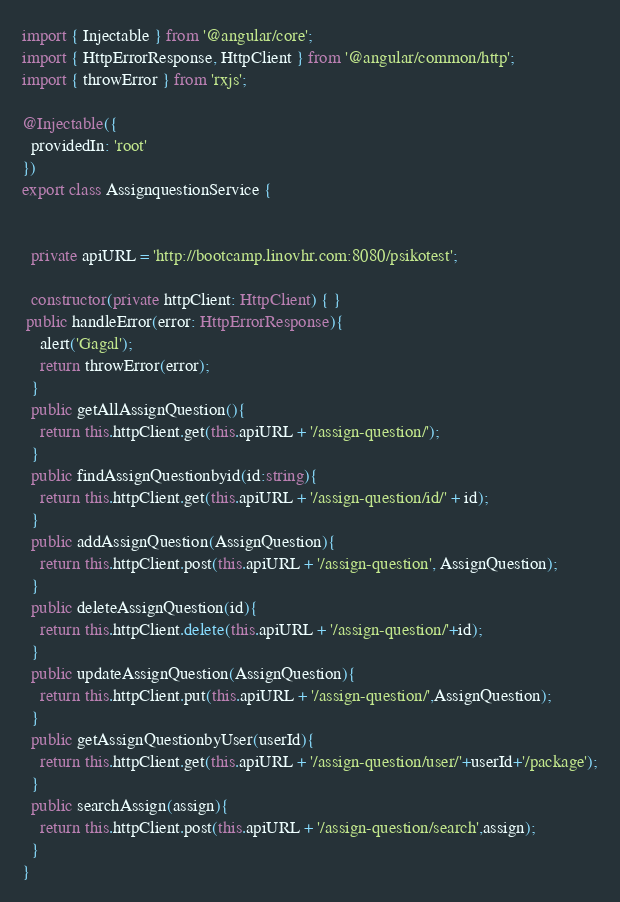<code> <loc_0><loc_0><loc_500><loc_500><_TypeScript_>import { Injectable } from '@angular/core';
import { HttpErrorResponse, HttpClient } from '@angular/common/http';
import { throwError } from 'rxjs';

@Injectable({
  providedIn: 'root'
})
export class AssignquestionService {


  private apiURL = 'http://bootcamp.linovhr.com:8080/psikotest';

  constructor(private httpClient: HttpClient) { }
 public handleError(error: HttpErrorResponse){
    alert('Gagal');
    return throwError(error);
  }
  public getAllAssignQuestion(){
    return this.httpClient.get(this.apiURL + '/assign-question/');
  }
  public findAssignQuestionbyid(id:string){
    return this.httpClient.get(this.apiURL + '/assign-question/id/' + id);
  }
  public addAssignQuestion(AssignQuestion){
    return this.httpClient.post(this.apiURL + '/assign-question', AssignQuestion);
  }
  public deleteAssignQuestion(id){
    return this.httpClient.delete(this.apiURL + '/assign-question/'+id);
  }
  public updateAssignQuestion(AssignQuestion){
    return this.httpClient.put(this.apiURL + '/assign-question/',AssignQuestion);
  }
  public getAssignQuestionbyUser(userId){
    return this.httpClient.get(this.apiURL + '/assign-question/user/'+userId+'/package');
  }
  public searchAssign(assign){
    return this.httpClient.post(this.apiURL + '/assign-question/search',assign);
  }
}
</code> 